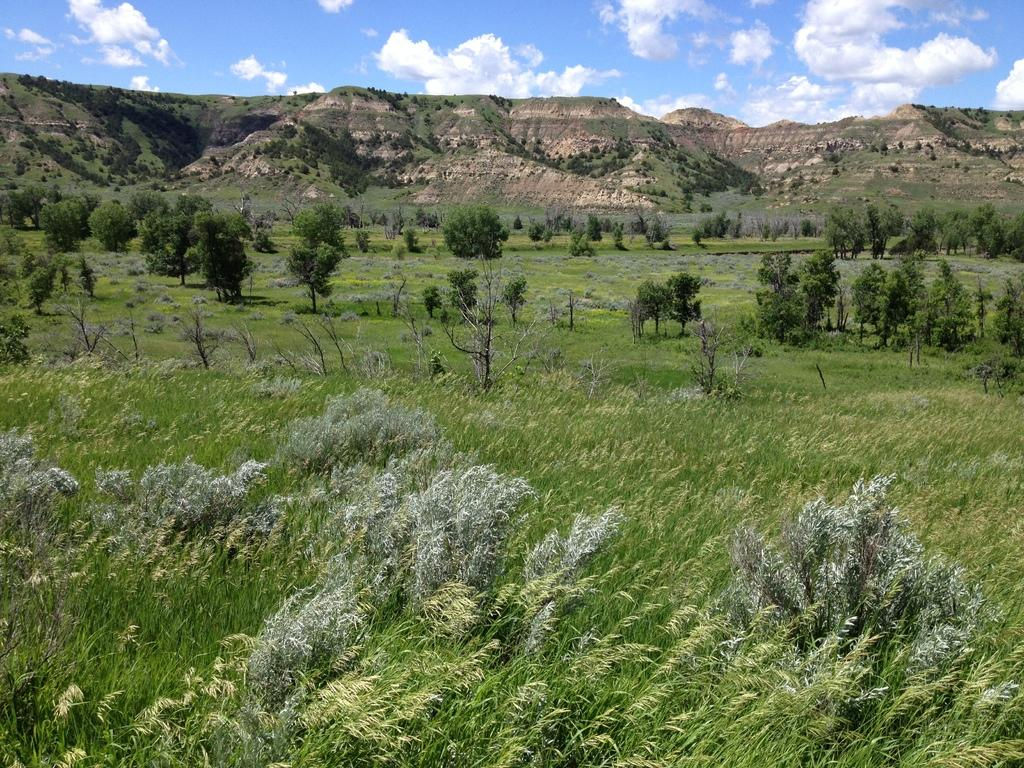What type of vegetation is at the bottom of the image? There is grass at the bottom of the image. What can be seen in the middle of the image? There are trees in the middle of the image. What type of landscape feature is visible in the background of the image? There are hills visible in the background of the image. What is visible at the top of the image? The sky is visible at the top of the image. What color is the thumb of the squirrel in the image? There is no squirrel present in the image, and therefore no thumb to describe. What type of silver object can be seen in the image? There is no silver object present in the image. 